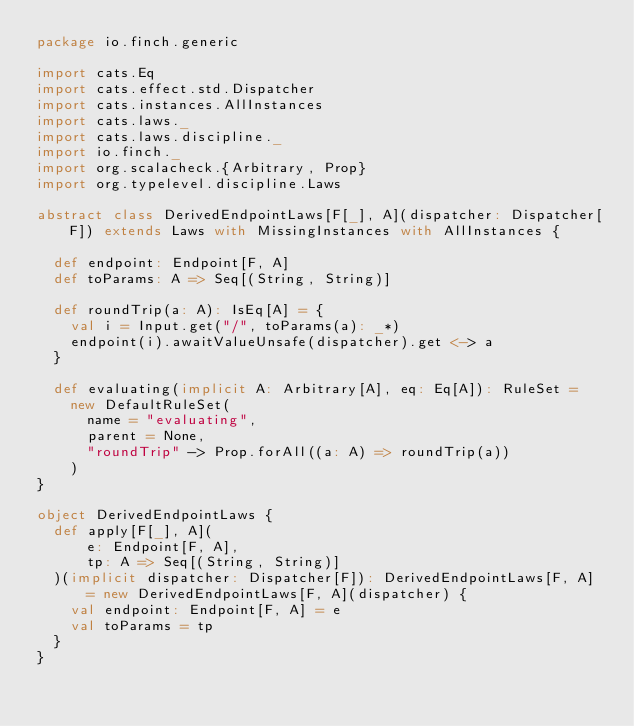<code> <loc_0><loc_0><loc_500><loc_500><_Scala_>package io.finch.generic

import cats.Eq
import cats.effect.std.Dispatcher
import cats.instances.AllInstances
import cats.laws._
import cats.laws.discipline._
import io.finch._
import org.scalacheck.{Arbitrary, Prop}
import org.typelevel.discipline.Laws

abstract class DerivedEndpointLaws[F[_], A](dispatcher: Dispatcher[F]) extends Laws with MissingInstances with AllInstances {

  def endpoint: Endpoint[F, A]
  def toParams: A => Seq[(String, String)]

  def roundTrip(a: A): IsEq[A] = {
    val i = Input.get("/", toParams(a): _*)
    endpoint(i).awaitValueUnsafe(dispatcher).get <-> a
  }

  def evaluating(implicit A: Arbitrary[A], eq: Eq[A]): RuleSet =
    new DefaultRuleSet(
      name = "evaluating",
      parent = None,
      "roundTrip" -> Prop.forAll((a: A) => roundTrip(a))
    )
}

object DerivedEndpointLaws {
  def apply[F[_], A](
      e: Endpoint[F, A],
      tp: A => Seq[(String, String)]
  )(implicit dispatcher: Dispatcher[F]): DerivedEndpointLaws[F, A] = new DerivedEndpointLaws[F, A](dispatcher) {
    val endpoint: Endpoint[F, A] = e
    val toParams = tp
  }
}
</code> 